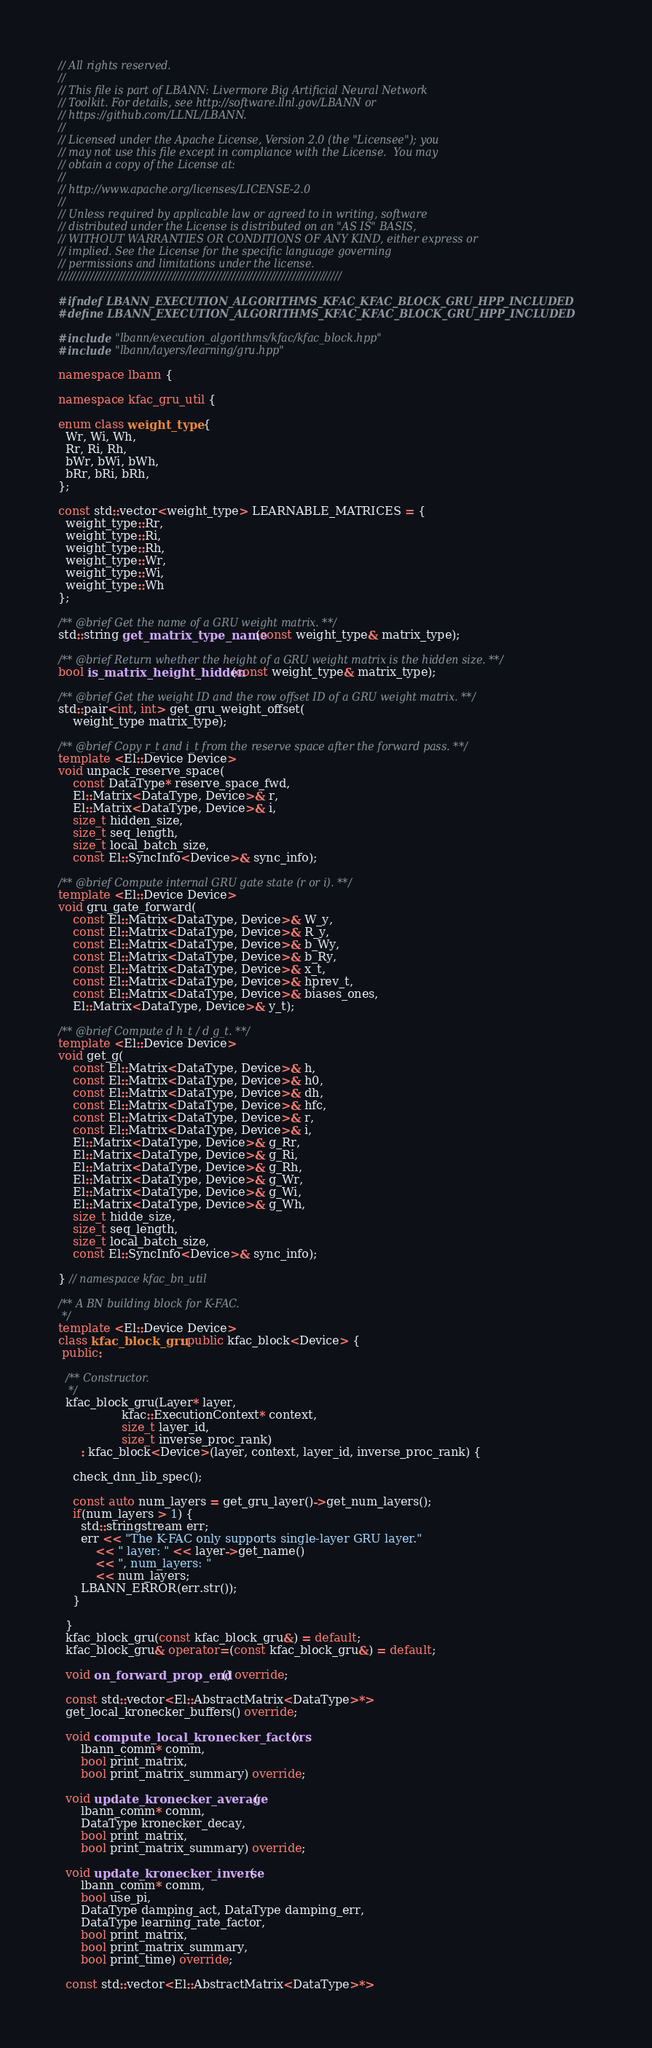Convert code to text. <code><loc_0><loc_0><loc_500><loc_500><_C++_>// All rights reserved.
//
// This file is part of LBANN: Livermore Big Artificial Neural Network
// Toolkit. For details, see http://software.llnl.gov/LBANN or
// https://github.com/LLNL/LBANN.
//
// Licensed under the Apache License, Version 2.0 (the "Licensee"); you
// may not use this file except in compliance with the License.  You may
// obtain a copy of the License at:
//
// http://www.apache.org/licenses/LICENSE-2.0
//
// Unless required by applicable law or agreed to in writing, software
// distributed under the License is distributed on an "AS IS" BASIS,
// WITHOUT WARRANTIES OR CONDITIONS OF ANY KIND, either express or
// implied. See the License for the specific language governing
// permissions and limitations under the license.
////////////////////////////////////////////////////////////////////////////////

#ifndef LBANN_EXECUTION_ALGORITHMS_KFAC_KFAC_BLOCK_GRU_HPP_INCLUDED
#define LBANN_EXECUTION_ALGORITHMS_KFAC_KFAC_BLOCK_GRU_HPP_INCLUDED

#include "lbann/execution_algorithms/kfac/kfac_block.hpp"
#include "lbann/layers/learning/gru.hpp"

namespace lbann {

namespace kfac_gru_util {

enum class weight_type {
  Wr, Wi, Wh,
  Rr, Ri, Rh,
  bWr, bWi, bWh,
  bRr, bRi, bRh,
};

const std::vector<weight_type> LEARNABLE_MATRICES = {
  weight_type::Rr,
  weight_type::Ri,
  weight_type::Rh,
  weight_type::Wr,
  weight_type::Wi,
  weight_type::Wh
};

/** @brief Get the name of a GRU weight matrix. **/
std::string get_matrix_type_name(const weight_type& matrix_type);

/** @brief Return whether the height of a GRU weight matrix is the hidden size. **/
bool is_matrix_height_hidden(const weight_type& matrix_type);

/** @brief Get the weight ID and the row offset ID of a GRU weight matrix. **/
std::pair<int, int> get_gru_weight_offset(
    weight_type matrix_type);

/** @brief Copy r_t and i_t from the reserve space after the forward pass. **/
template <El::Device Device>
void unpack_reserve_space(
    const DataType* reserve_space_fwd,
    El::Matrix<DataType, Device>& r,
    El::Matrix<DataType, Device>& i,
    size_t hidden_size,
    size_t seq_length,
    size_t local_batch_size,
    const El::SyncInfo<Device>& sync_info);

/** @brief Compute internal GRU gate state (r or i). **/
template <El::Device Device>
void gru_gate_forward(
    const El::Matrix<DataType, Device>& W_y,
    const El::Matrix<DataType, Device>& R_y,
    const El::Matrix<DataType, Device>& b_Wy,
    const El::Matrix<DataType, Device>& b_Ry,
    const El::Matrix<DataType, Device>& x_t,
    const El::Matrix<DataType, Device>& hprev_t,
    const El::Matrix<DataType, Device>& biases_ones,
    El::Matrix<DataType, Device>& y_t);

/** @brief Compute d h_t / d g_t. **/
template <El::Device Device>
void get_g(
    const El::Matrix<DataType, Device>& h,
    const El::Matrix<DataType, Device>& h0,
    const El::Matrix<DataType, Device>& dh,
    const El::Matrix<DataType, Device>& hfc,
    const El::Matrix<DataType, Device>& r,
    const El::Matrix<DataType, Device>& i,
    El::Matrix<DataType, Device>& g_Rr,
    El::Matrix<DataType, Device>& g_Ri,
    El::Matrix<DataType, Device>& g_Rh,
    El::Matrix<DataType, Device>& g_Wr,
    El::Matrix<DataType, Device>& g_Wi,
    El::Matrix<DataType, Device>& g_Wh,
    size_t hidde_size,
    size_t seq_length,
    size_t local_batch_size,
    const El::SyncInfo<Device>& sync_info);

} // namespace kfac_bn_util

/** A BN building block for K-FAC.
 */
template <El::Device Device>
class kfac_block_gru: public kfac_block<Device> {
 public:

  /** Constructor.
   */
  kfac_block_gru(Layer* layer,
                 kfac::ExecutionContext* context,
                 size_t layer_id,
                 size_t inverse_proc_rank)
      : kfac_block<Device>(layer, context, layer_id, inverse_proc_rank) {

    check_dnn_lib_spec();

    const auto num_layers = get_gru_layer()->get_num_layers();
    if(num_layers > 1) {
      std::stringstream err;
      err << "The K-FAC only supports single-layer GRU layer."
          << " layer: " << layer->get_name()
          << ", num_layers: "
          << num_layers;
      LBANN_ERROR(err.str());
    }

  }
  kfac_block_gru(const kfac_block_gru&) = default;
  kfac_block_gru& operator=(const kfac_block_gru&) = default;

  void on_forward_prop_end() override;

  const std::vector<El::AbstractMatrix<DataType>*>
  get_local_kronecker_buffers() override;

  void compute_local_kronecker_factors(
      lbann_comm* comm,
      bool print_matrix,
      bool print_matrix_summary) override;

  void update_kronecker_average(
      lbann_comm* comm,
      DataType kronecker_decay,
      bool print_matrix,
      bool print_matrix_summary) override;

  void update_kronecker_inverse(
      lbann_comm* comm,
      bool use_pi,
      DataType damping_act, DataType damping_err,
      DataType learning_rate_factor,
      bool print_matrix,
      bool print_matrix_summary,
      bool print_time) override;

  const std::vector<El::AbstractMatrix<DataType>*></code> 